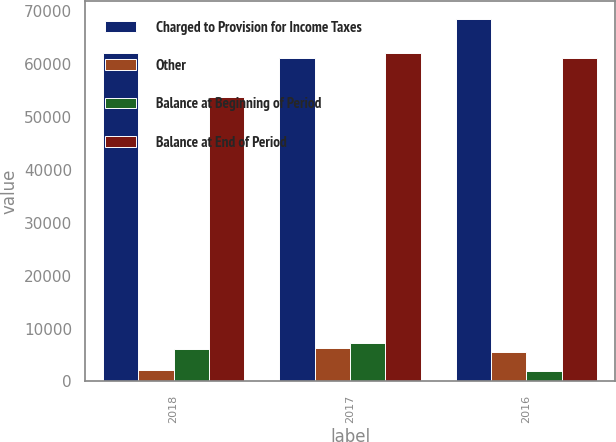Convert chart to OTSL. <chart><loc_0><loc_0><loc_500><loc_500><stacked_bar_chart><ecel><fcel>2018<fcel>2017<fcel>2016<nl><fcel>Charged to Provision for Income Taxes<fcel>62098<fcel>61225<fcel>68595<nl><fcel>Other<fcel>2128<fcel>6363<fcel>5473<nl><fcel>Balance at Beginning of Period<fcel>6077<fcel>7236<fcel>1897<nl><fcel>Balance at End of Period<fcel>53893<fcel>62098<fcel>61225<nl></chart> 